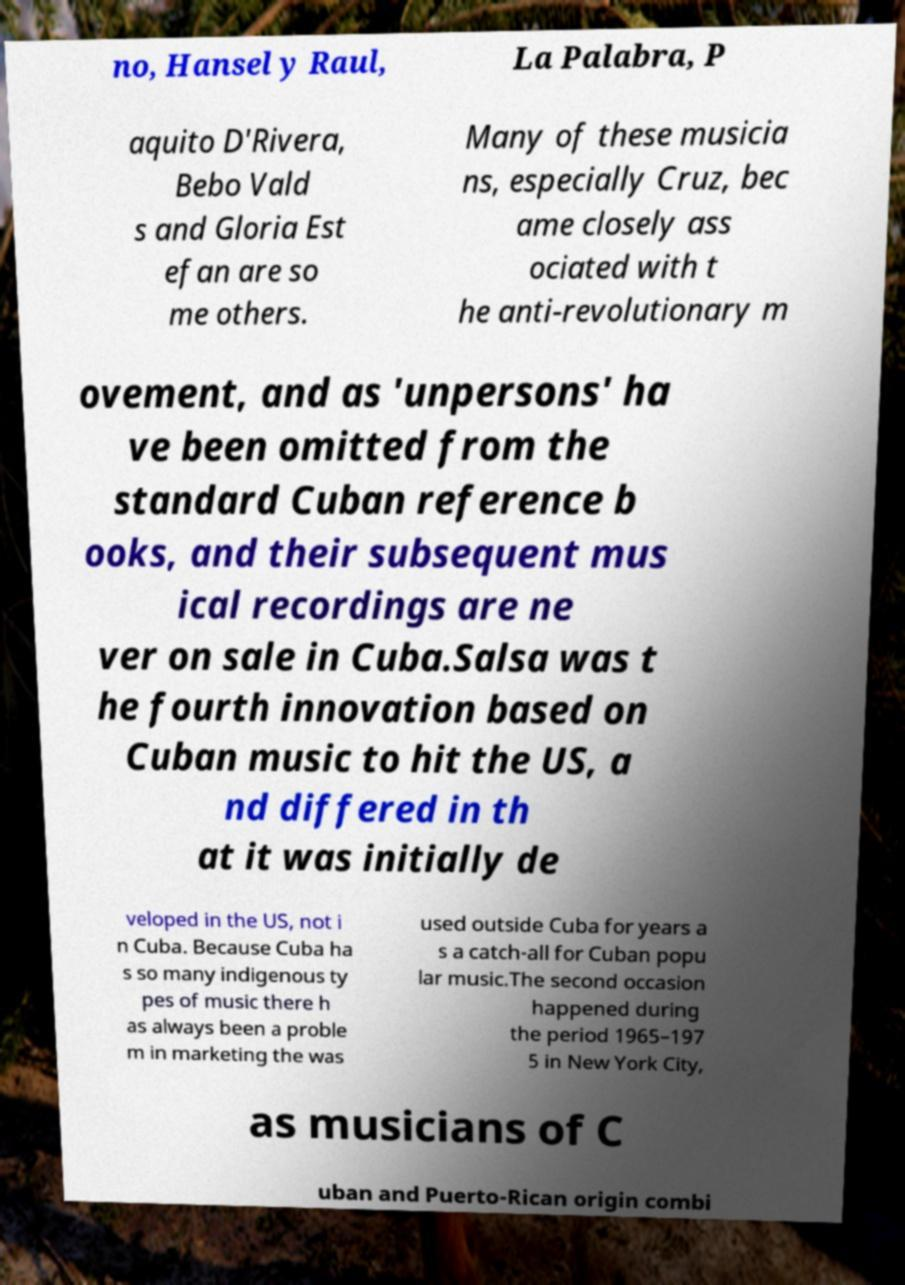What messages or text are displayed in this image? I need them in a readable, typed format. no, Hansel y Raul, La Palabra, P aquito D'Rivera, Bebo Vald s and Gloria Est efan are so me others. Many of these musicia ns, especially Cruz, bec ame closely ass ociated with t he anti-revolutionary m ovement, and as 'unpersons' ha ve been omitted from the standard Cuban reference b ooks, and their subsequent mus ical recordings are ne ver on sale in Cuba.Salsa was t he fourth innovation based on Cuban music to hit the US, a nd differed in th at it was initially de veloped in the US, not i n Cuba. Because Cuba ha s so many indigenous ty pes of music there h as always been a proble m in marketing the was used outside Cuba for years a s a catch-all for Cuban popu lar music.The second occasion happened during the period 1965–197 5 in New York City, as musicians of C uban and Puerto-Rican origin combi 